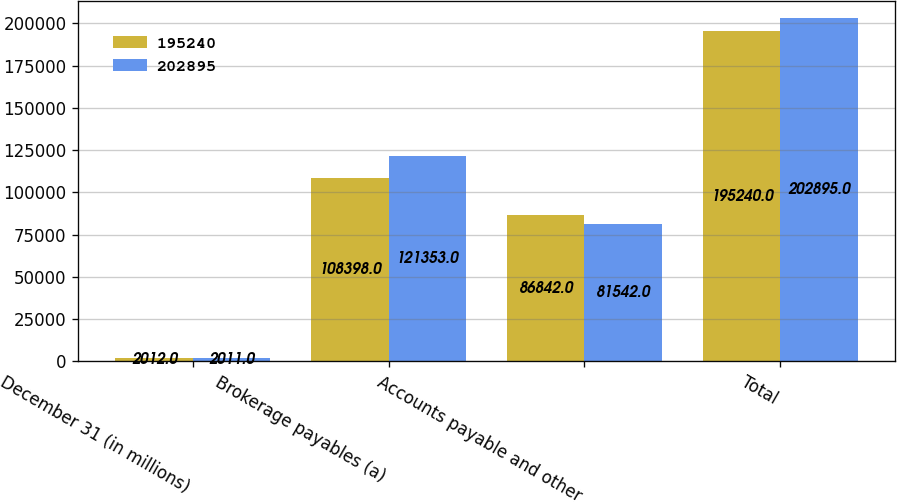Convert chart. <chart><loc_0><loc_0><loc_500><loc_500><stacked_bar_chart><ecel><fcel>December 31 (in millions)<fcel>Brokerage payables (a)<fcel>Accounts payable and other<fcel>Total<nl><fcel>195240<fcel>2012<fcel>108398<fcel>86842<fcel>195240<nl><fcel>202895<fcel>2011<fcel>121353<fcel>81542<fcel>202895<nl></chart> 